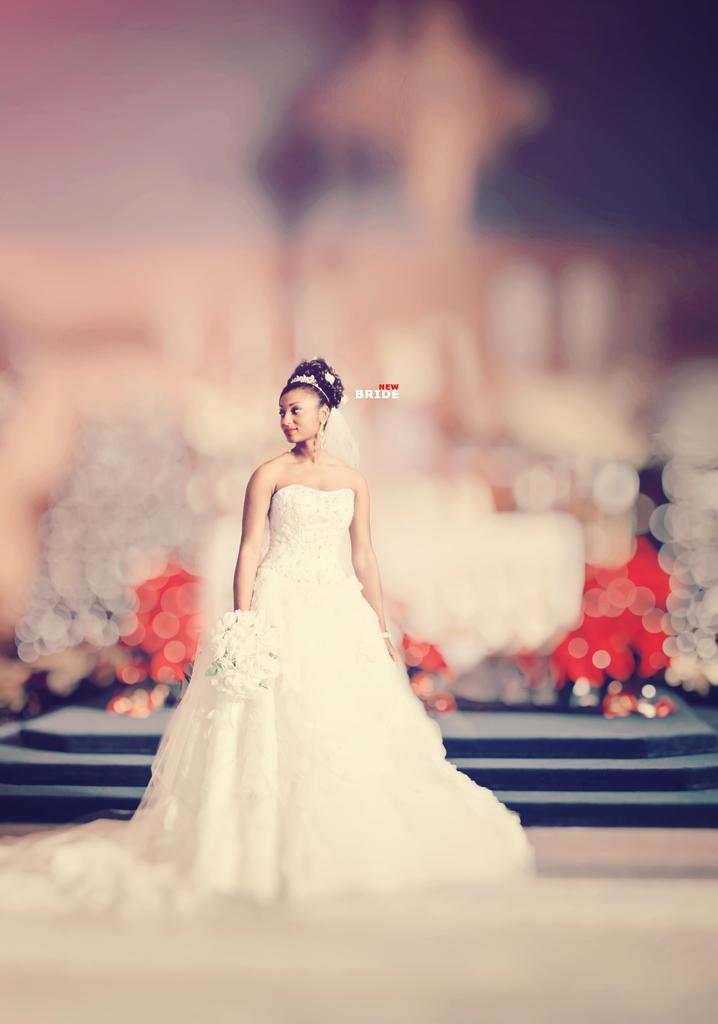How would you summarize this image in a sentence or two? In the picture I can see a woman wearing a white color dress is standing here. The background of the image is blurred, where we can see black color steps and a few objects. Here we can see some edited text. 